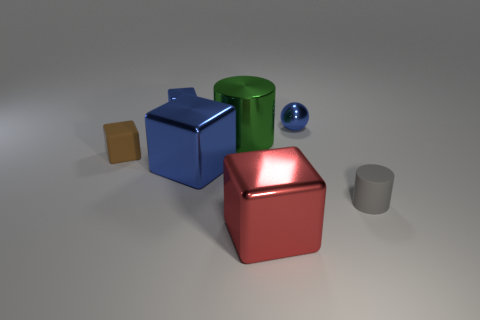Subtract all red cylinders. Subtract all green spheres. How many cylinders are left? 2 Add 1 blue shiny balls. How many objects exist? 8 Subtract all balls. How many objects are left? 6 Add 7 tiny matte cylinders. How many tiny matte cylinders are left? 8 Add 2 big yellow matte cubes. How many big yellow matte cubes exist? 2 Subtract 0 purple blocks. How many objects are left? 7 Subtract all small gray rubber cylinders. Subtract all large green metallic things. How many objects are left? 5 